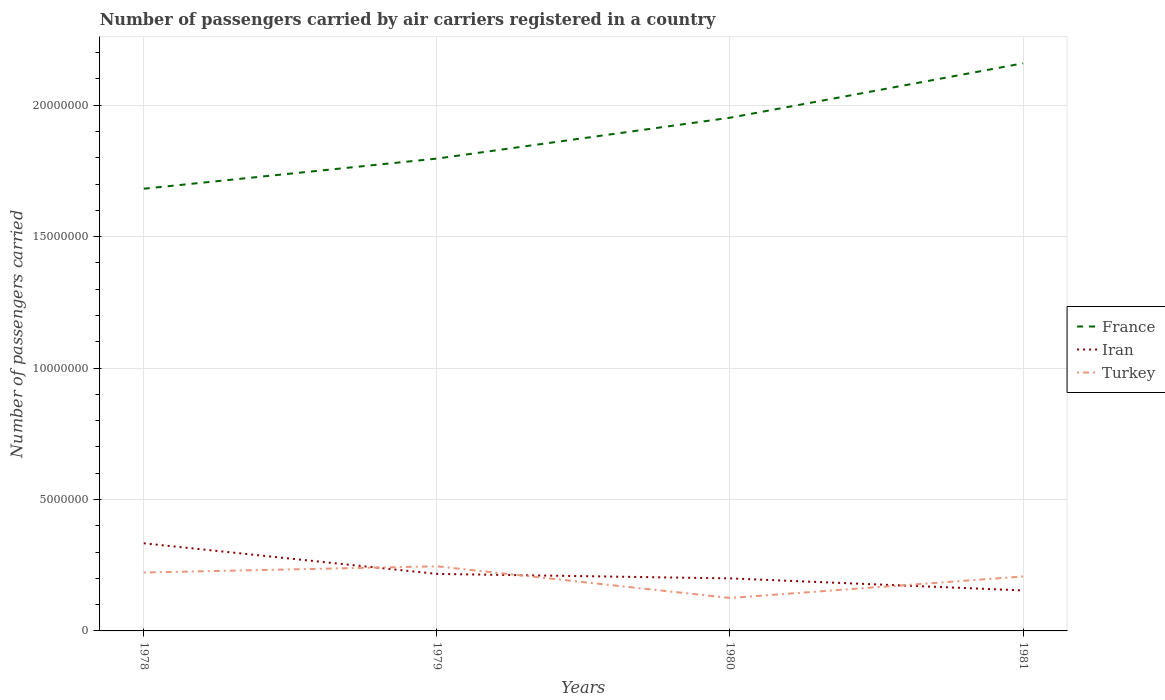Is the number of lines equal to the number of legend labels?
Your response must be concise. Yes. Across all years, what is the maximum number of passengers carried by air carriers in France?
Offer a terse response. 1.68e+07. In which year was the number of passengers carried by air carriers in Turkey maximum?
Make the answer very short. 1980. What is the total number of passengers carried by air carriers in France in the graph?
Ensure brevity in your answer.  -2.07e+06. What is the difference between the highest and the second highest number of passengers carried by air carriers in France?
Your response must be concise. 4.77e+06. Is the number of passengers carried by air carriers in France strictly greater than the number of passengers carried by air carriers in Iran over the years?
Make the answer very short. No. How many years are there in the graph?
Your answer should be very brief. 4. What is the difference between two consecutive major ticks on the Y-axis?
Make the answer very short. 5.00e+06. Are the values on the major ticks of Y-axis written in scientific E-notation?
Make the answer very short. No. Does the graph contain grids?
Offer a terse response. Yes. How are the legend labels stacked?
Make the answer very short. Vertical. What is the title of the graph?
Give a very brief answer. Number of passengers carried by air carriers registered in a country. Does "Sri Lanka" appear as one of the legend labels in the graph?
Your response must be concise. No. What is the label or title of the Y-axis?
Your answer should be compact. Number of passengers carried. What is the Number of passengers carried of France in 1978?
Provide a short and direct response. 1.68e+07. What is the Number of passengers carried of Iran in 1978?
Make the answer very short. 3.33e+06. What is the Number of passengers carried in Turkey in 1978?
Ensure brevity in your answer.  2.22e+06. What is the Number of passengers carried of France in 1979?
Give a very brief answer. 1.80e+07. What is the Number of passengers carried of Iran in 1979?
Provide a short and direct response. 2.17e+06. What is the Number of passengers carried of Turkey in 1979?
Make the answer very short. 2.46e+06. What is the Number of passengers carried in France in 1980?
Provide a short and direct response. 1.95e+07. What is the Number of passengers carried of Iran in 1980?
Make the answer very short. 2.00e+06. What is the Number of passengers carried in Turkey in 1980?
Offer a terse response. 1.25e+06. What is the Number of passengers carried of France in 1981?
Provide a succinct answer. 2.16e+07. What is the Number of passengers carried of Iran in 1981?
Your response must be concise. 1.54e+06. What is the Number of passengers carried of Turkey in 1981?
Give a very brief answer. 2.07e+06. Across all years, what is the maximum Number of passengers carried of France?
Your answer should be very brief. 2.16e+07. Across all years, what is the maximum Number of passengers carried of Iran?
Give a very brief answer. 3.33e+06. Across all years, what is the maximum Number of passengers carried of Turkey?
Your answer should be compact. 2.46e+06. Across all years, what is the minimum Number of passengers carried in France?
Provide a short and direct response. 1.68e+07. Across all years, what is the minimum Number of passengers carried in Iran?
Make the answer very short. 1.54e+06. Across all years, what is the minimum Number of passengers carried of Turkey?
Offer a very short reply. 1.25e+06. What is the total Number of passengers carried in France in the graph?
Make the answer very short. 7.59e+07. What is the total Number of passengers carried of Iran in the graph?
Keep it short and to the point. 9.04e+06. What is the total Number of passengers carried of Turkey in the graph?
Offer a very short reply. 8.00e+06. What is the difference between the Number of passengers carried in France in 1978 and that in 1979?
Provide a short and direct response. -1.15e+06. What is the difference between the Number of passengers carried of Iran in 1978 and that in 1979?
Offer a terse response. 1.16e+06. What is the difference between the Number of passengers carried in Turkey in 1978 and that in 1979?
Provide a short and direct response. -2.37e+05. What is the difference between the Number of passengers carried of France in 1978 and that in 1980?
Your response must be concise. -2.70e+06. What is the difference between the Number of passengers carried of Iran in 1978 and that in 1980?
Make the answer very short. 1.34e+06. What is the difference between the Number of passengers carried in Turkey in 1978 and that in 1980?
Give a very brief answer. 9.68e+05. What is the difference between the Number of passengers carried in France in 1978 and that in 1981?
Your answer should be compact. -4.77e+06. What is the difference between the Number of passengers carried of Iran in 1978 and that in 1981?
Your answer should be compact. 1.79e+06. What is the difference between the Number of passengers carried of Turkey in 1978 and that in 1981?
Your response must be concise. 1.50e+05. What is the difference between the Number of passengers carried of France in 1979 and that in 1980?
Give a very brief answer. -1.55e+06. What is the difference between the Number of passengers carried of Iran in 1979 and that in 1980?
Provide a short and direct response. 1.71e+05. What is the difference between the Number of passengers carried in Turkey in 1979 and that in 1980?
Make the answer very short. 1.20e+06. What is the difference between the Number of passengers carried in France in 1979 and that in 1981?
Your answer should be very brief. -3.62e+06. What is the difference between the Number of passengers carried of Iran in 1979 and that in 1981?
Give a very brief answer. 6.29e+05. What is the difference between the Number of passengers carried in Turkey in 1979 and that in 1981?
Give a very brief answer. 3.87e+05. What is the difference between the Number of passengers carried in France in 1980 and that in 1981?
Keep it short and to the point. -2.07e+06. What is the difference between the Number of passengers carried of Iran in 1980 and that in 1981?
Your answer should be very brief. 4.58e+05. What is the difference between the Number of passengers carried in Turkey in 1980 and that in 1981?
Your answer should be very brief. -8.18e+05. What is the difference between the Number of passengers carried in France in 1978 and the Number of passengers carried in Iran in 1979?
Keep it short and to the point. 1.47e+07. What is the difference between the Number of passengers carried of France in 1978 and the Number of passengers carried of Turkey in 1979?
Keep it short and to the point. 1.44e+07. What is the difference between the Number of passengers carried in Iran in 1978 and the Number of passengers carried in Turkey in 1979?
Your response must be concise. 8.75e+05. What is the difference between the Number of passengers carried in France in 1978 and the Number of passengers carried in Iran in 1980?
Your answer should be compact. 1.48e+07. What is the difference between the Number of passengers carried in France in 1978 and the Number of passengers carried in Turkey in 1980?
Make the answer very short. 1.56e+07. What is the difference between the Number of passengers carried of Iran in 1978 and the Number of passengers carried of Turkey in 1980?
Offer a terse response. 2.08e+06. What is the difference between the Number of passengers carried in France in 1978 and the Number of passengers carried in Iran in 1981?
Make the answer very short. 1.53e+07. What is the difference between the Number of passengers carried of France in 1978 and the Number of passengers carried of Turkey in 1981?
Give a very brief answer. 1.47e+07. What is the difference between the Number of passengers carried in Iran in 1978 and the Number of passengers carried in Turkey in 1981?
Offer a very short reply. 1.26e+06. What is the difference between the Number of passengers carried in France in 1979 and the Number of passengers carried in Iran in 1980?
Keep it short and to the point. 1.60e+07. What is the difference between the Number of passengers carried in France in 1979 and the Number of passengers carried in Turkey in 1980?
Your answer should be compact. 1.67e+07. What is the difference between the Number of passengers carried in Iran in 1979 and the Number of passengers carried in Turkey in 1980?
Make the answer very short. 9.15e+05. What is the difference between the Number of passengers carried of France in 1979 and the Number of passengers carried of Iran in 1981?
Your response must be concise. 1.64e+07. What is the difference between the Number of passengers carried of France in 1979 and the Number of passengers carried of Turkey in 1981?
Your answer should be compact. 1.59e+07. What is the difference between the Number of passengers carried of Iran in 1979 and the Number of passengers carried of Turkey in 1981?
Give a very brief answer. 9.74e+04. What is the difference between the Number of passengers carried of France in 1980 and the Number of passengers carried of Iran in 1981?
Provide a succinct answer. 1.80e+07. What is the difference between the Number of passengers carried in France in 1980 and the Number of passengers carried in Turkey in 1981?
Provide a succinct answer. 1.74e+07. What is the difference between the Number of passengers carried of Iran in 1980 and the Number of passengers carried of Turkey in 1981?
Your answer should be very brief. -7.32e+04. What is the average Number of passengers carried in France per year?
Make the answer very short. 1.90e+07. What is the average Number of passengers carried in Iran per year?
Offer a terse response. 2.26e+06. What is the average Number of passengers carried of Turkey per year?
Ensure brevity in your answer.  2.00e+06. In the year 1978, what is the difference between the Number of passengers carried of France and Number of passengers carried of Iran?
Make the answer very short. 1.35e+07. In the year 1978, what is the difference between the Number of passengers carried of France and Number of passengers carried of Turkey?
Offer a very short reply. 1.46e+07. In the year 1978, what is the difference between the Number of passengers carried in Iran and Number of passengers carried in Turkey?
Provide a short and direct response. 1.11e+06. In the year 1979, what is the difference between the Number of passengers carried in France and Number of passengers carried in Iran?
Offer a terse response. 1.58e+07. In the year 1979, what is the difference between the Number of passengers carried in France and Number of passengers carried in Turkey?
Keep it short and to the point. 1.55e+07. In the year 1979, what is the difference between the Number of passengers carried in Iran and Number of passengers carried in Turkey?
Give a very brief answer. -2.90e+05. In the year 1980, what is the difference between the Number of passengers carried of France and Number of passengers carried of Iran?
Offer a terse response. 1.75e+07. In the year 1980, what is the difference between the Number of passengers carried of France and Number of passengers carried of Turkey?
Provide a short and direct response. 1.83e+07. In the year 1980, what is the difference between the Number of passengers carried in Iran and Number of passengers carried in Turkey?
Offer a terse response. 7.44e+05. In the year 1981, what is the difference between the Number of passengers carried in France and Number of passengers carried in Iran?
Provide a short and direct response. 2.01e+07. In the year 1981, what is the difference between the Number of passengers carried in France and Number of passengers carried in Turkey?
Offer a terse response. 1.95e+07. In the year 1981, what is the difference between the Number of passengers carried of Iran and Number of passengers carried of Turkey?
Your response must be concise. -5.32e+05. What is the ratio of the Number of passengers carried in France in 1978 to that in 1979?
Provide a short and direct response. 0.94. What is the ratio of the Number of passengers carried of Iran in 1978 to that in 1979?
Give a very brief answer. 1.54. What is the ratio of the Number of passengers carried of Turkey in 1978 to that in 1979?
Provide a succinct answer. 0.9. What is the ratio of the Number of passengers carried in France in 1978 to that in 1980?
Offer a terse response. 0.86. What is the ratio of the Number of passengers carried in Iran in 1978 to that in 1980?
Provide a short and direct response. 1.67. What is the ratio of the Number of passengers carried in Turkey in 1978 to that in 1980?
Provide a short and direct response. 1.77. What is the ratio of the Number of passengers carried in France in 1978 to that in 1981?
Offer a terse response. 0.78. What is the ratio of the Number of passengers carried in Iran in 1978 to that in 1981?
Make the answer very short. 2.17. What is the ratio of the Number of passengers carried in Turkey in 1978 to that in 1981?
Provide a succinct answer. 1.07. What is the ratio of the Number of passengers carried of France in 1979 to that in 1980?
Make the answer very short. 0.92. What is the ratio of the Number of passengers carried in Iran in 1979 to that in 1980?
Offer a terse response. 1.09. What is the ratio of the Number of passengers carried in Turkey in 1979 to that in 1980?
Your response must be concise. 1.96. What is the ratio of the Number of passengers carried in France in 1979 to that in 1981?
Keep it short and to the point. 0.83. What is the ratio of the Number of passengers carried of Iran in 1979 to that in 1981?
Ensure brevity in your answer.  1.41. What is the ratio of the Number of passengers carried of Turkey in 1979 to that in 1981?
Provide a short and direct response. 1.19. What is the ratio of the Number of passengers carried in France in 1980 to that in 1981?
Your response must be concise. 0.9. What is the ratio of the Number of passengers carried in Iran in 1980 to that in 1981?
Make the answer very short. 1.3. What is the ratio of the Number of passengers carried in Turkey in 1980 to that in 1981?
Offer a terse response. 0.61. What is the difference between the highest and the second highest Number of passengers carried in France?
Make the answer very short. 2.07e+06. What is the difference between the highest and the second highest Number of passengers carried in Iran?
Provide a succinct answer. 1.16e+06. What is the difference between the highest and the second highest Number of passengers carried in Turkey?
Provide a short and direct response. 2.37e+05. What is the difference between the highest and the lowest Number of passengers carried of France?
Ensure brevity in your answer.  4.77e+06. What is the difference between the highest and the lowest Number of passengers carried of Iran?
Your response must be concise. 1.79e+06. What is the difference between the highest and the lowest Number of passengers carried in Turkey?
Offer a terse response. 1.20e+06. 